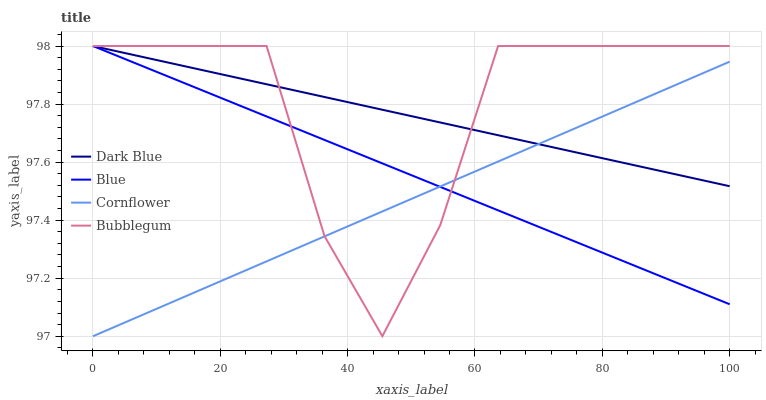Does Cornflower have the minimum area under the curve?
Answer yes or no. Yes. Does Bubblegum have the maximum area under the curve?
Answer yes or no. Yes. Does Dark Blue have the minimum area under the curve?
Answer yes or no. No. Does Dark Blue have the maximum area under the curve?
Answer yes or no. No. Is Cornflower the smoothest?
Answer yes or no. Yes. Is Bubblegum the roughest?
Answer yes or no. Yes. Is Dark Blue the smoothest?
Answer yes or no. No. Is Dark Blue the roughest?
Answer yes or no. No. Does Cornflower have the lowest value?
Answer yes or no. Yes. Does Bubblegum have the lowest value?
Answer yes or no. No. Does Bubblegum have the highest value?
Answer yes or no. Yes. Does Cornflower have the highest value?
Answer yes or no. No. Does Blue intersect Dark Blue?
Answer yes or no. Yes. Is Blue less than Dark Blue?
Answer yes or no. No. Is Blue greater than Dark Blue?
Answer yes or no. No. 